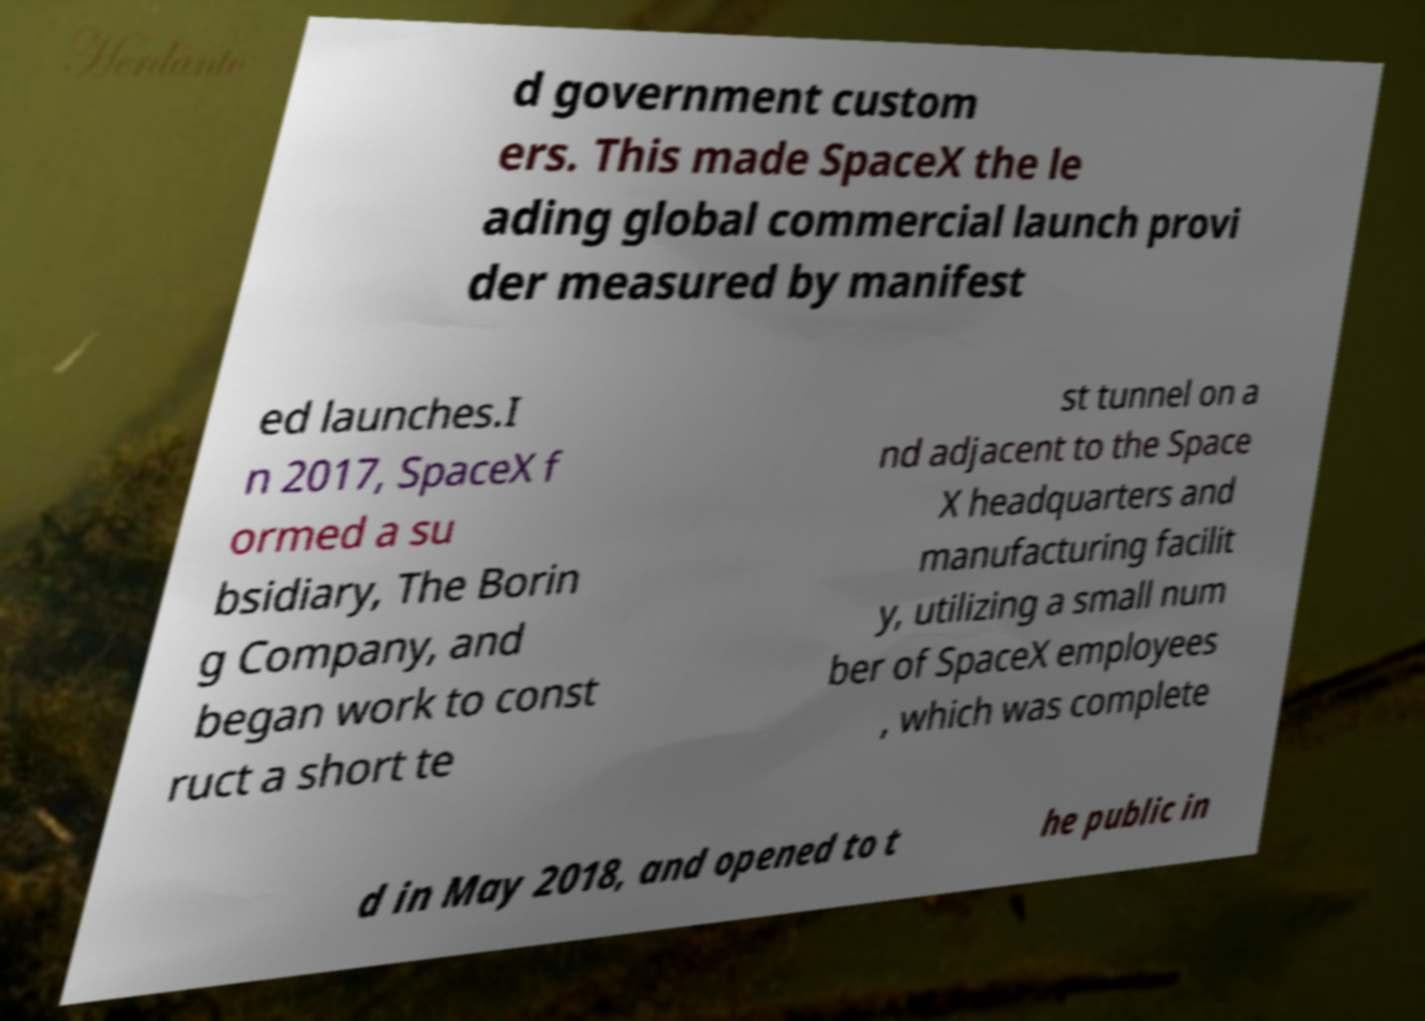I need the written content from this picture converted into text. Can you do that? d government custom ers. This made SpaceX the le ading global commercial launch provi der measured by manifest ed launches.I n 2017, SpaceX f ormed a su bsidiary, The Borin g Company, and began work to const ruct a short te st tunnel on a nd adjacent to the Space X headquarters and manufacturing facilit y, utilizing a small num ber of SpaceX employees , which was complete d in May 2018, and opened to t he public in 